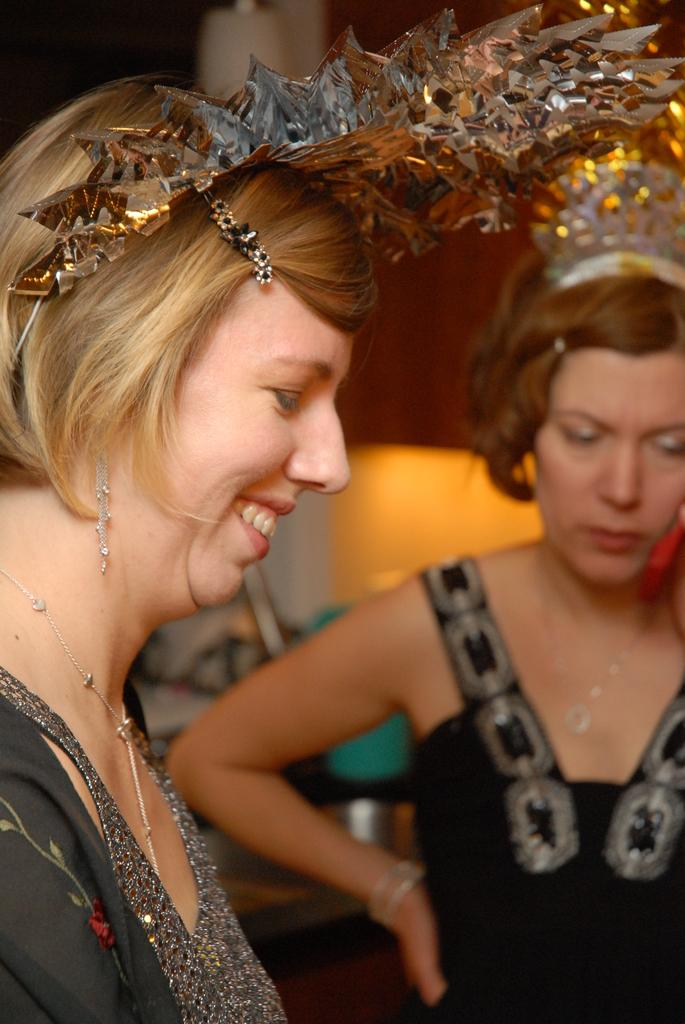How many people are in the image? There are two people in the image. What colors are the dresses of the people in the image? One person is wearing a black dress, and the other person is wearing a grey dress. What headpieces are the people wearing in the image? Both people are wearing crowns. Can you describe the background of the image? The background of the image is blurred. What type of circle can be seen in the image? There is no circle present in the image. What health benefits can be gained from the image? The image does not depict any health-related information or objects, so it is not possible to determine any health benefits from the image. 